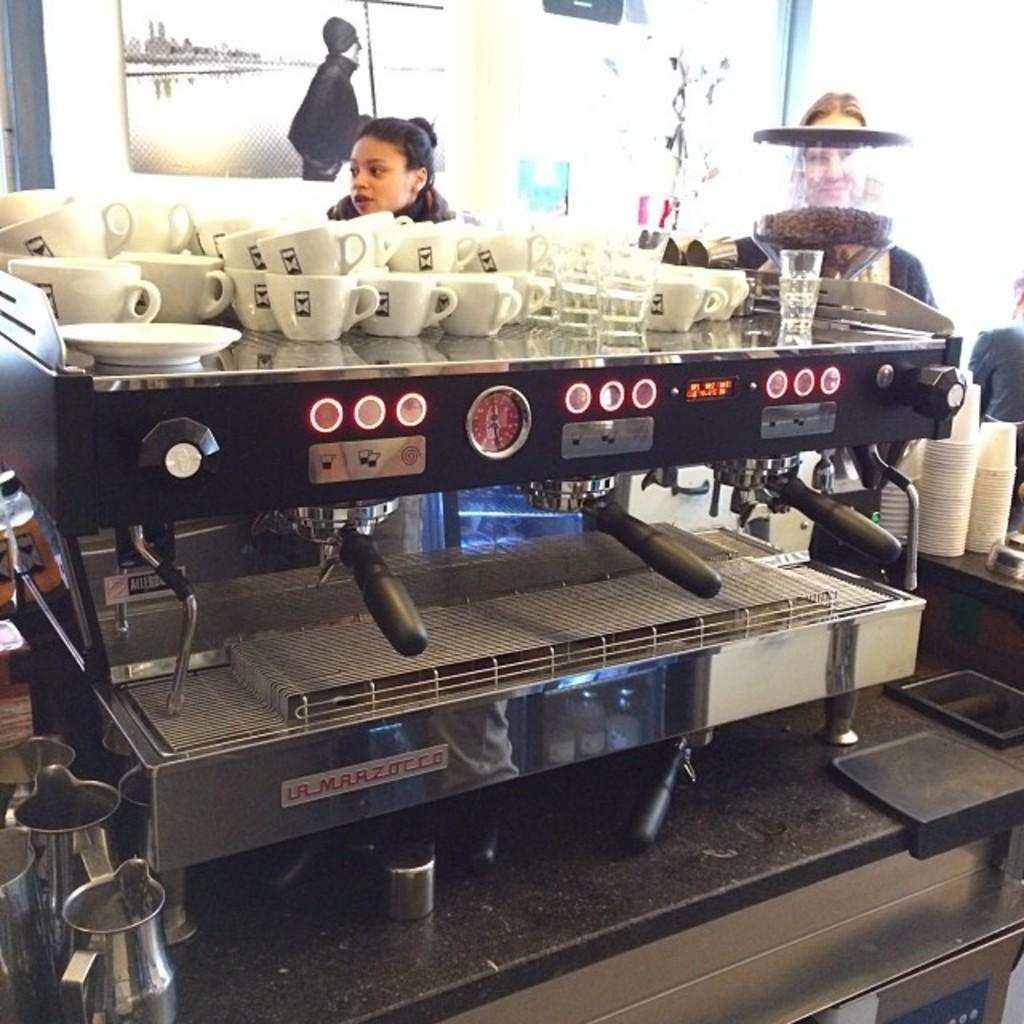<image>
Provide a brief description of the given image. A huge coffee maker from La Marzocco in a cafe. 